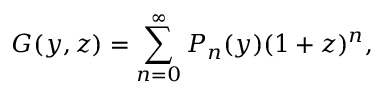Convert formula to latex. <formula><loc_0><loc_0><loc_500><loc_500>G ( y , z ) = \sum _ { n = 0 } ^ { \infty } P _ { n } ( y ) ( 1 + z ) ^ { n } ,</formula> 